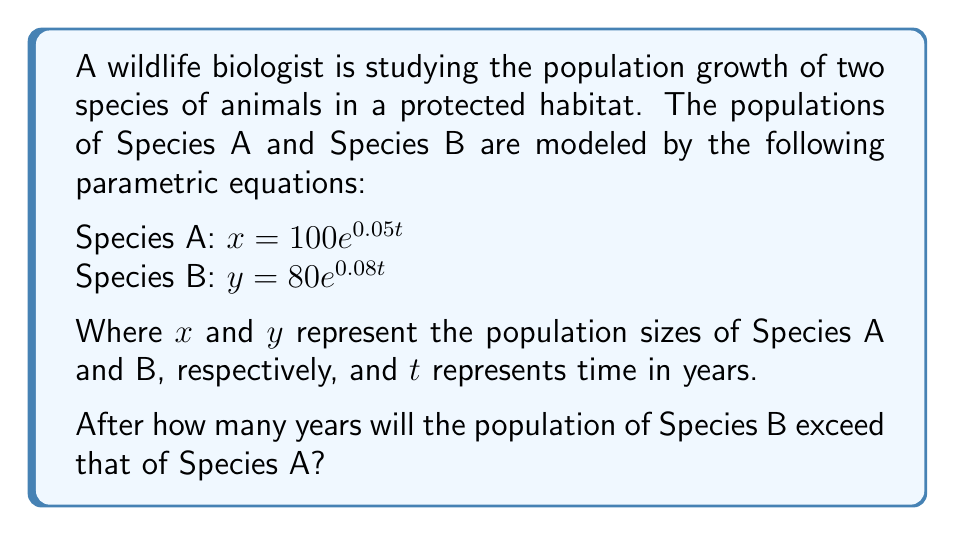Could you help me with this problem? To solve this problem, we need to find the time $t$ when the population of Species B ($y$) becomes greater than the population of Species A ($x$). We can do this by setting up an inequality:

1) Set up the inequality:
   $80e^{0.08t} > 100e^{0.05t}$

2) Take the natural logarithm of both sides:
   $\ln(80e^{0.08t}) > \ln(100e^{0.05t})$

3) Use the logarithm property $\ln(ab) = \ln(a) + \ln(b)$:
   $\ln(80) + 0.08t > \ln(100) + 0.05t$

4) Simplify:
   $4.38 + 0.08t > 4.61 + 0.05t$

5) Subtract 4.38 from both sides:
   $0.08t > 0.23 + 0.05t$

6) Subtract 0.05t from both sides:
   $0.03t > 0.23$

7) Divide both sides by 0.03:
   $t > 7.67$

Since time must be a whole number of years in this context, we round up to the next integer.
Answer: The population of Species B will exceed that of Species A after 8 years. 